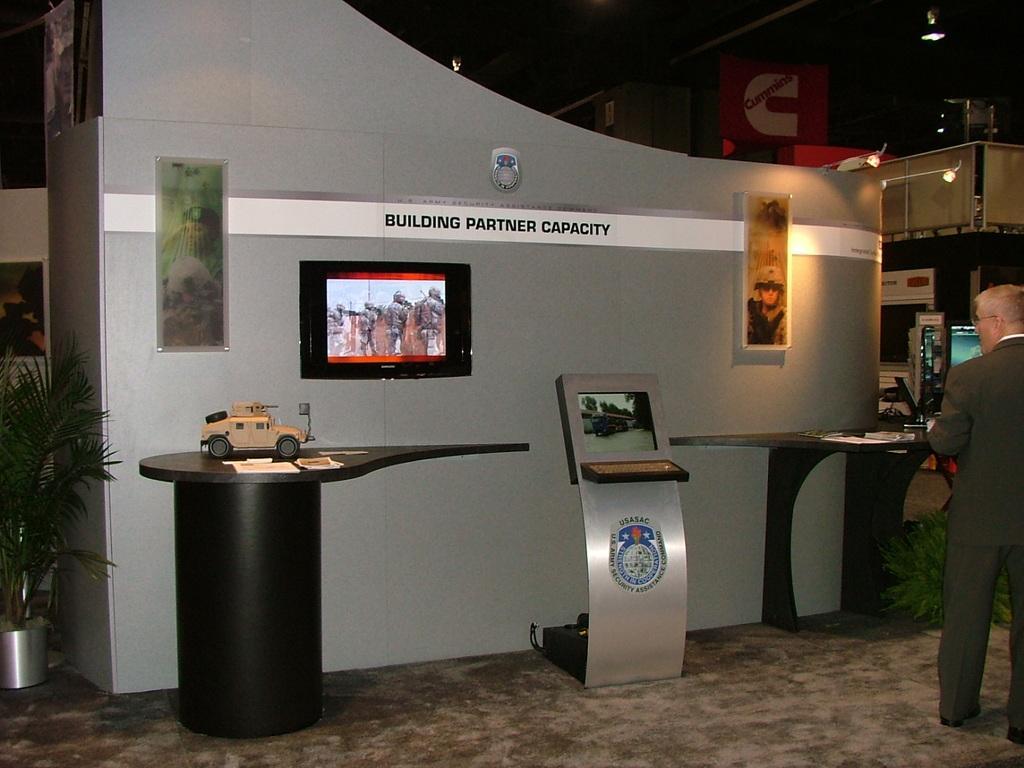In one or two sentences, can you explain what this image depicts? This image is taken inside a room. In the right side of the image a man is standing. At the bottom of the image there is a floor with mat. At the top of the image there is a ceiling with lights. At the background there is a wall with frames on it. In the left side of the image there is a plant with pot. 